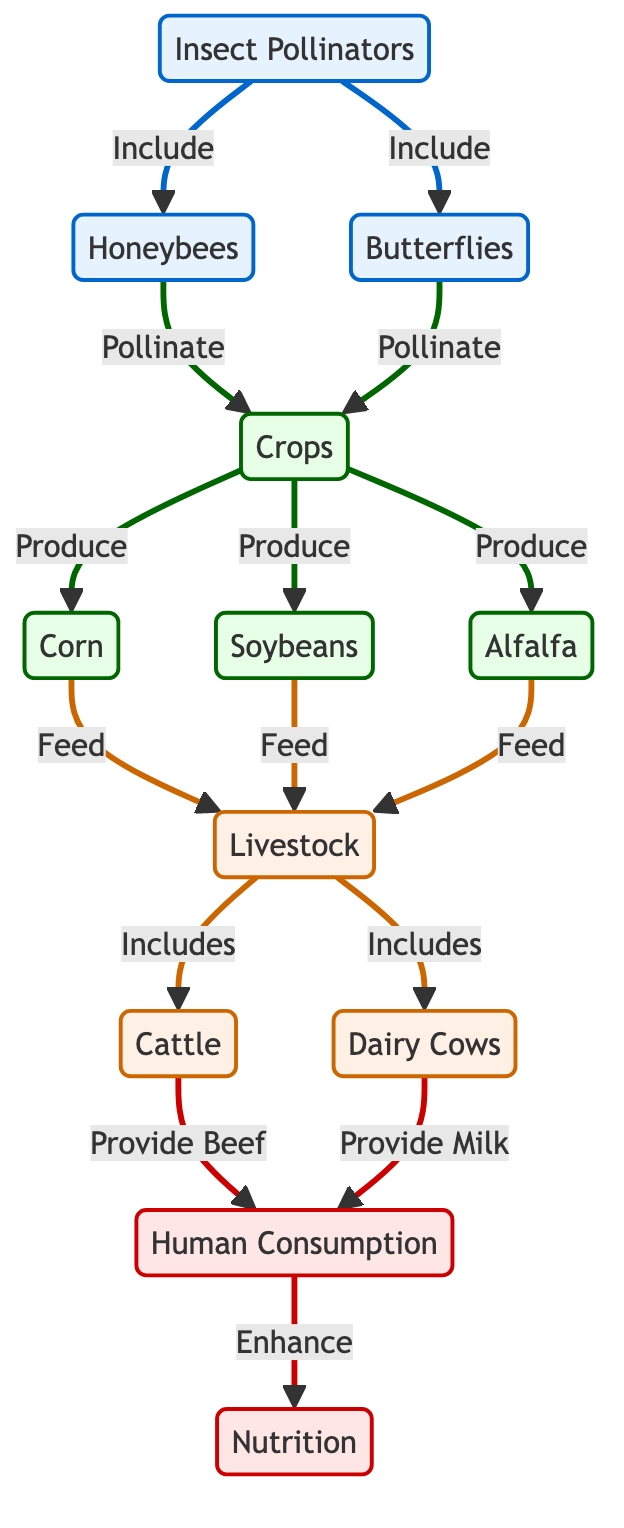What are the main insect pollinators mentioned? The diagram lists "Honeybees" and "Butterflies" as the main insect pollinators contained within the "Insect Pollinators" node.
Answer: Honeybees, Butterflies How many crops are produced from the pollinated crops? The diagram shows three crops: "Corn", "Soybeans", and "Alfalfa" which come from the "Crops" node that are pollinated by the insect pollinators.
Answer: Three What do the crops feed? According to the diagram, the "Crops" such as corn, soybeans, and alfalfa feed "Livestock", indicating that the crops have a direct feeding relationship with livestock.
Answer: Livestock What type of livestock is mentioned in the diagram? The diagram identifies "Cattle" and "Dairy Cows" as types of livestock that are included under the "Livestock" node, thus illustrating the types of livestock sourced from the crops.
Answer: Cattle, Dairy Cows Which crops provide feed for livestock? The diagram states that "Corn", "Soybeans", and "Alfalfa" are the crops that provide feed for livestock, indicating a crucial relationship between these crops and livestock production.
Answer: Corn, Soybeans, Alfalfa Which food products enhance human nutrition? The diagram indicates that "Beef" from "Cattle" and "Milk" from "Dairy" are the food products that ultimately enhance human nutrition through the "Human Consumption" node.
Answer: Beef, Milk How many edges are connected to the crops node? In the diagram, there are four edges connected to the "Crops" node: one to "Honeybees", one to "Butterflies", one to "Corn", and one to "Soybeans". Therefore, counting these connections gives a total of four edges.
Answer: Four What is the relationship between livestock and human consumption? The diagram illustrates that livestock that includes cattle and dairy provide "Beef" and "Milk" to the "Human Consumption" node, showing a direct relationship where livestock contributes to human food sources.
Answer: Provides Beef, Provides Milk What is the overall context of the food chain depicted in the diagram? The diagram represents the relationship between insect-driven pollination, crop production, livestock feeding, and ultimately human consumption, establishing the flow from pollinators to agricultural and food production systems.
Answer: Insect-Driven Pollination to Crop Yield to Livestock to Human Consumption 